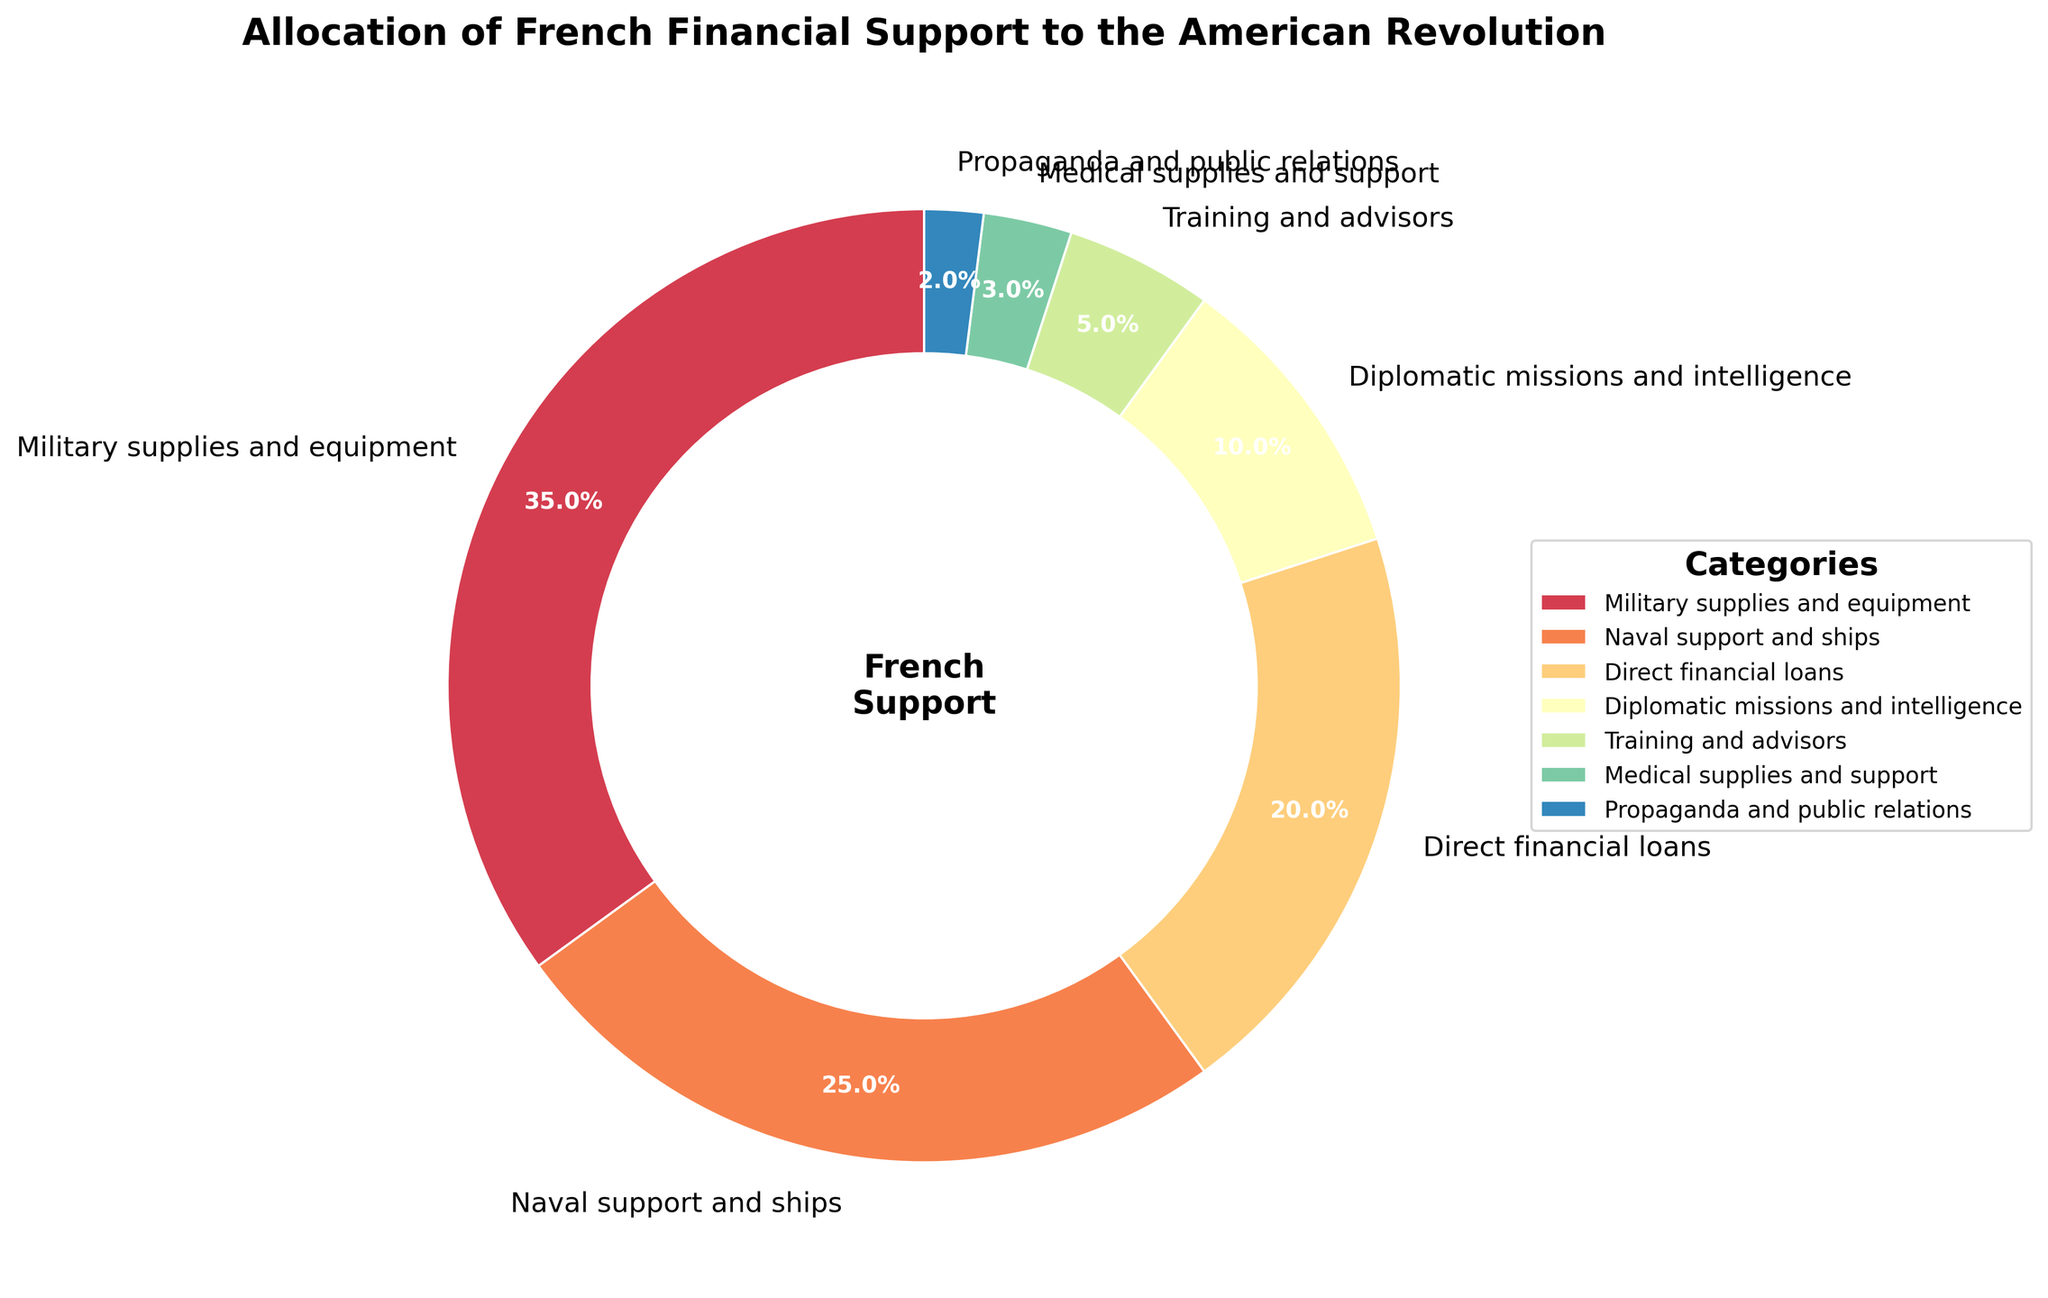What category received the highest percentage of French financial support during the American Revolution? The pie chart shows that "Military supplies and equipment" takes up the largest portion of the chart with 35%.
Answer: Military supplies and equipment What is the total percentage of French financial support allocated to Naval support and ships, and Direct financial loans combined? Sum the percentages of "Naval support and ships" (25%) and "Direct financial loans" (20%) to find the combined percentage.
Answer: 45% Which category received less financial support: Medical supplies and support, or Propaganda and public relations? By comparing the two slices, "Medical supplies and support" is shown with 3%, and "Propaganda and public relations" with 2%.
Answer: Propaganda and public relations How does the French financial support for Diplomatic missions and intelligence compare to Training and advisors? Diplomatic missions and intelligence got 10%, while Training and advisors got 5%, indicating Diplomatic missions and intelligence received double the funding.
Answer: Diplomatic missions and intelligence received double What percentage of French financial support went towards non-military purposes? Consider Diplomatic missions and intelligence, Medical supplies and support, and Propaganda and public relations. Add the percentages of Diplomatic missions and intelligence (10%), Medical supplies and support (3%), and Propaganda and public relations (2%) for the total non-military support.
Answer: 15% 